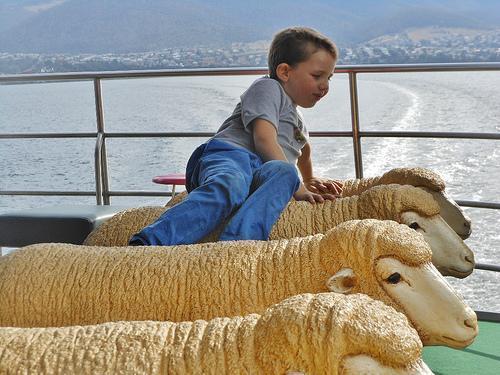How many kids are shown?
Give a very brief answer. 1. How many fake sheep are shown?
Give a very brief answer. 4. How many sheep are showing?
Give a very brief answer. 4. 